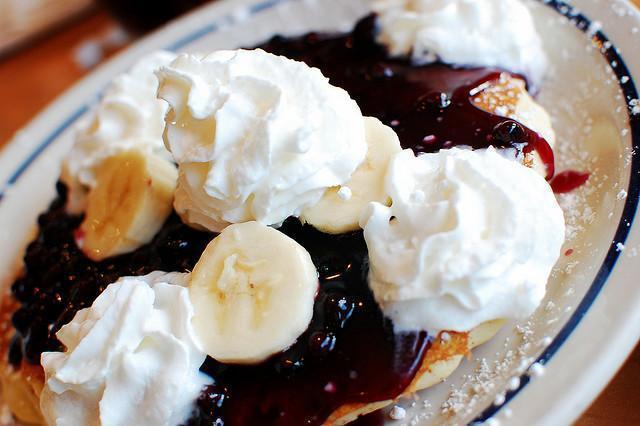What type of breakfast food is this on the plate?
Choose the correct response and explain in the format: 'Answer: answer
Rationale: rationale.'
Options: Waffle, egg, pancake, biscuit. Answer: pancake.
Rationale: This is a pancake with some whipped cream and banana slices. 